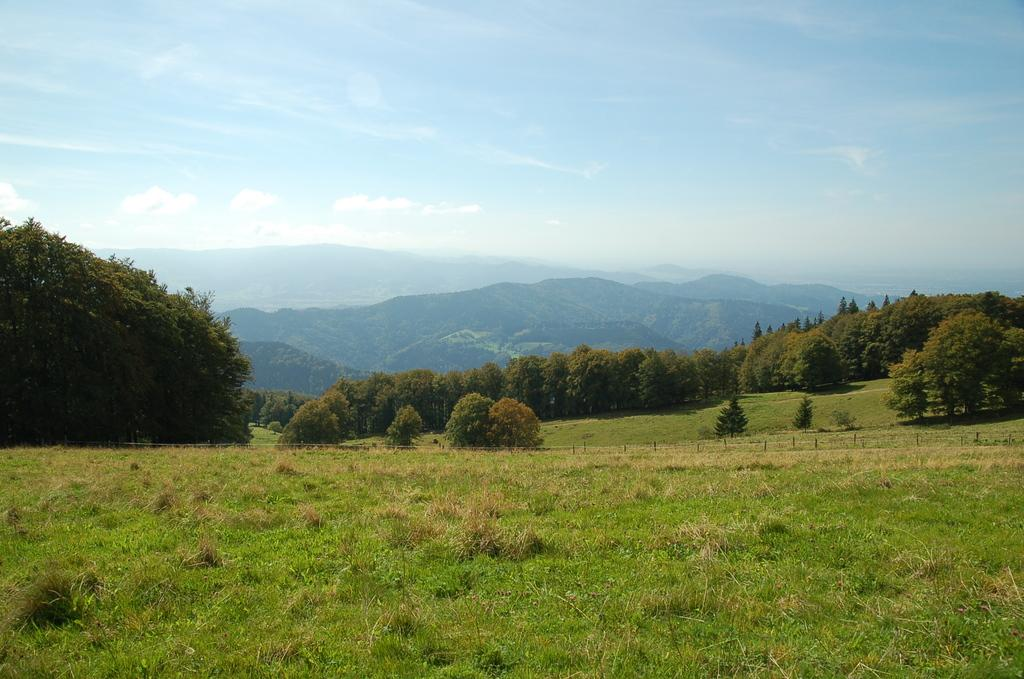What type of terrain is visible in the foreground of the image? There is a grassland in the foreground of the image. What type of vegetation can be seen in the background of the image? There are trees in the background of the image. What type of geological feature is visible in the background of the image? There are mountains in the background of the image. What is visible above the mountains in the image? The sky is visible in the background of the image. What type of riddle is hidden within the frame of the image? There is no riddle hidden within the frame of the image; it is a simple depiction of a grassland, trees, mountains, and the sky. 